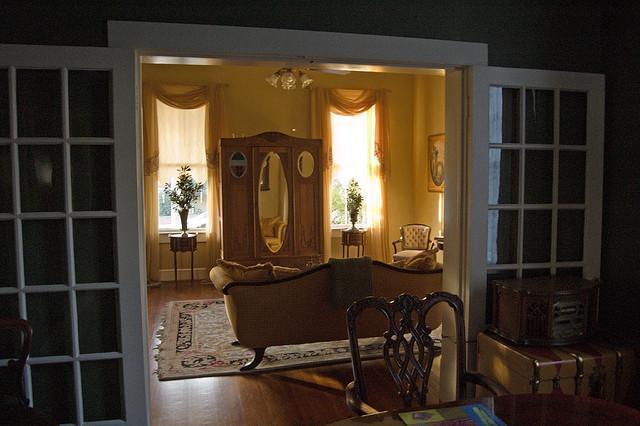What is at the far end of the room?
From the following set of four choices, select the accurate answer to respond to the question.
Options: Mirror, dog, cat, baby. Mirror. 